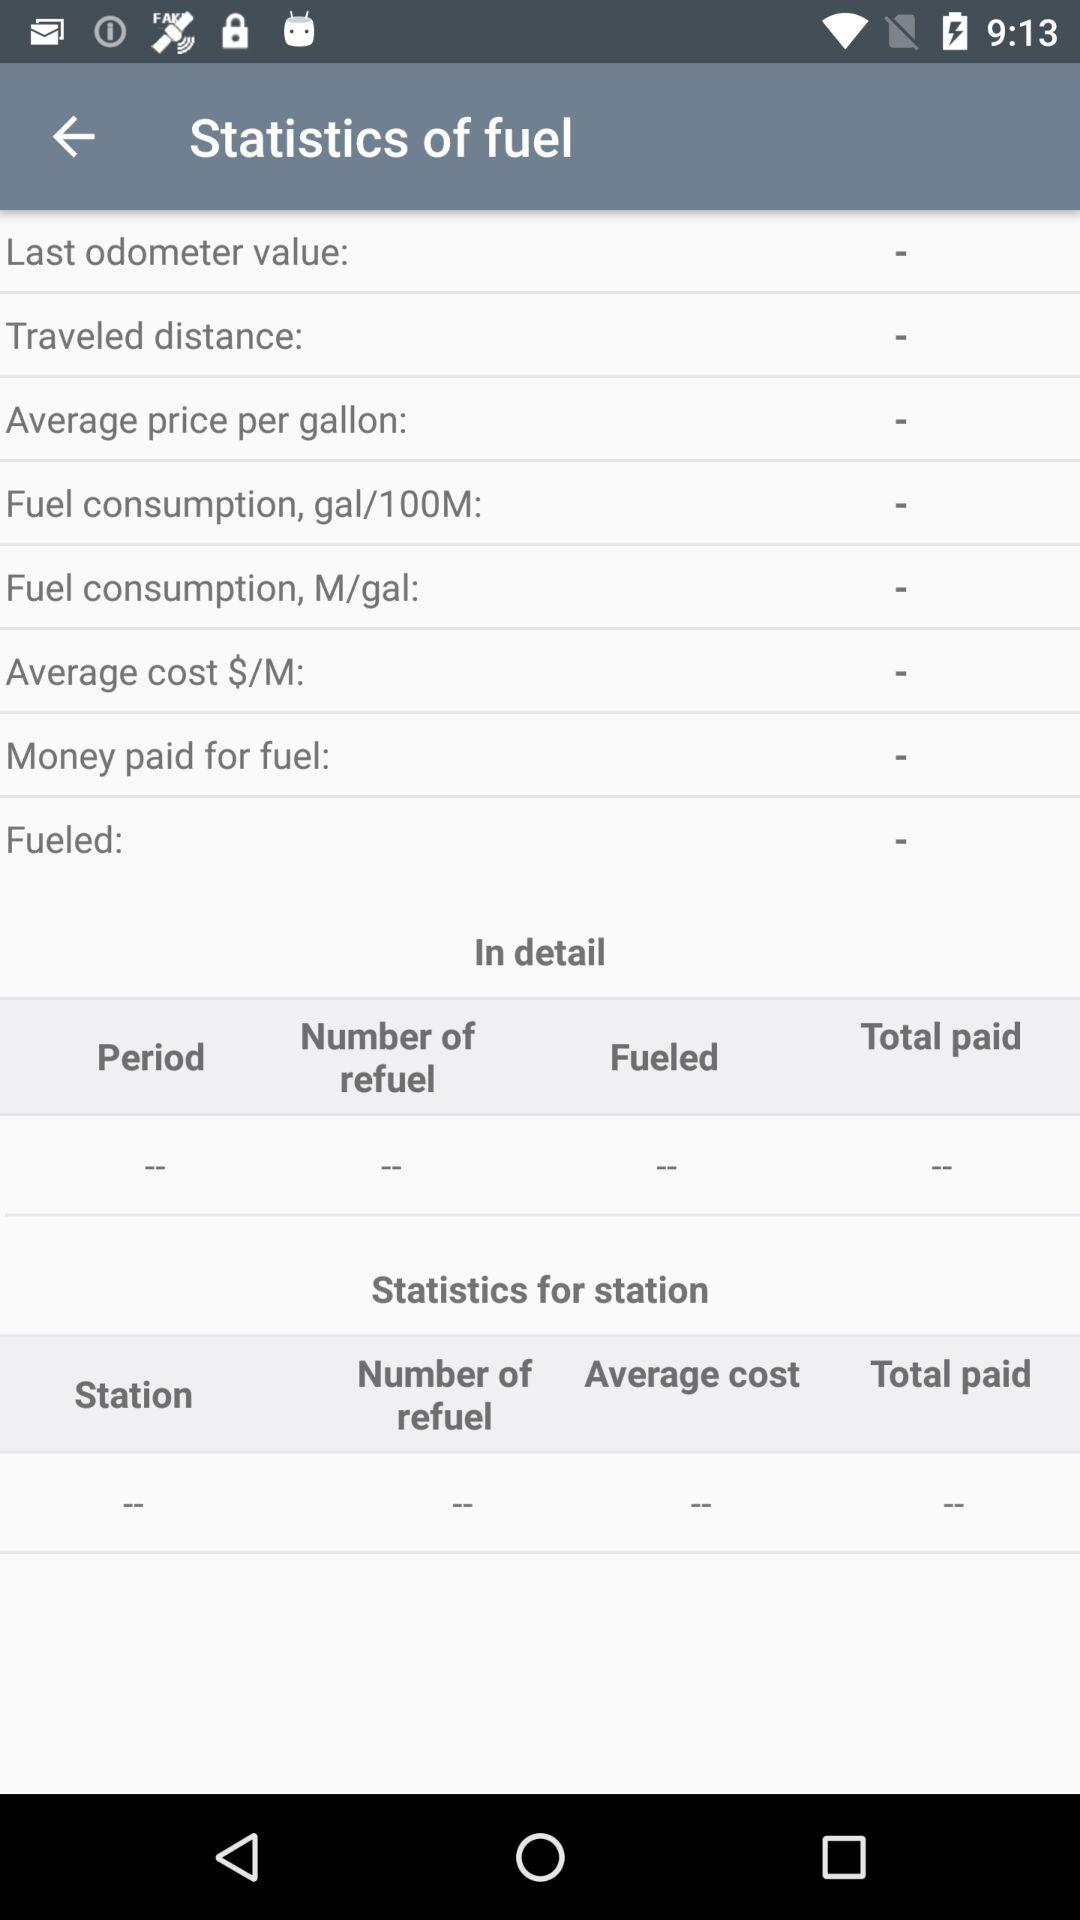What's the measurement unit for fuel consumption? The measurement unit for fuel consumption are gal/100M and M/gal. 